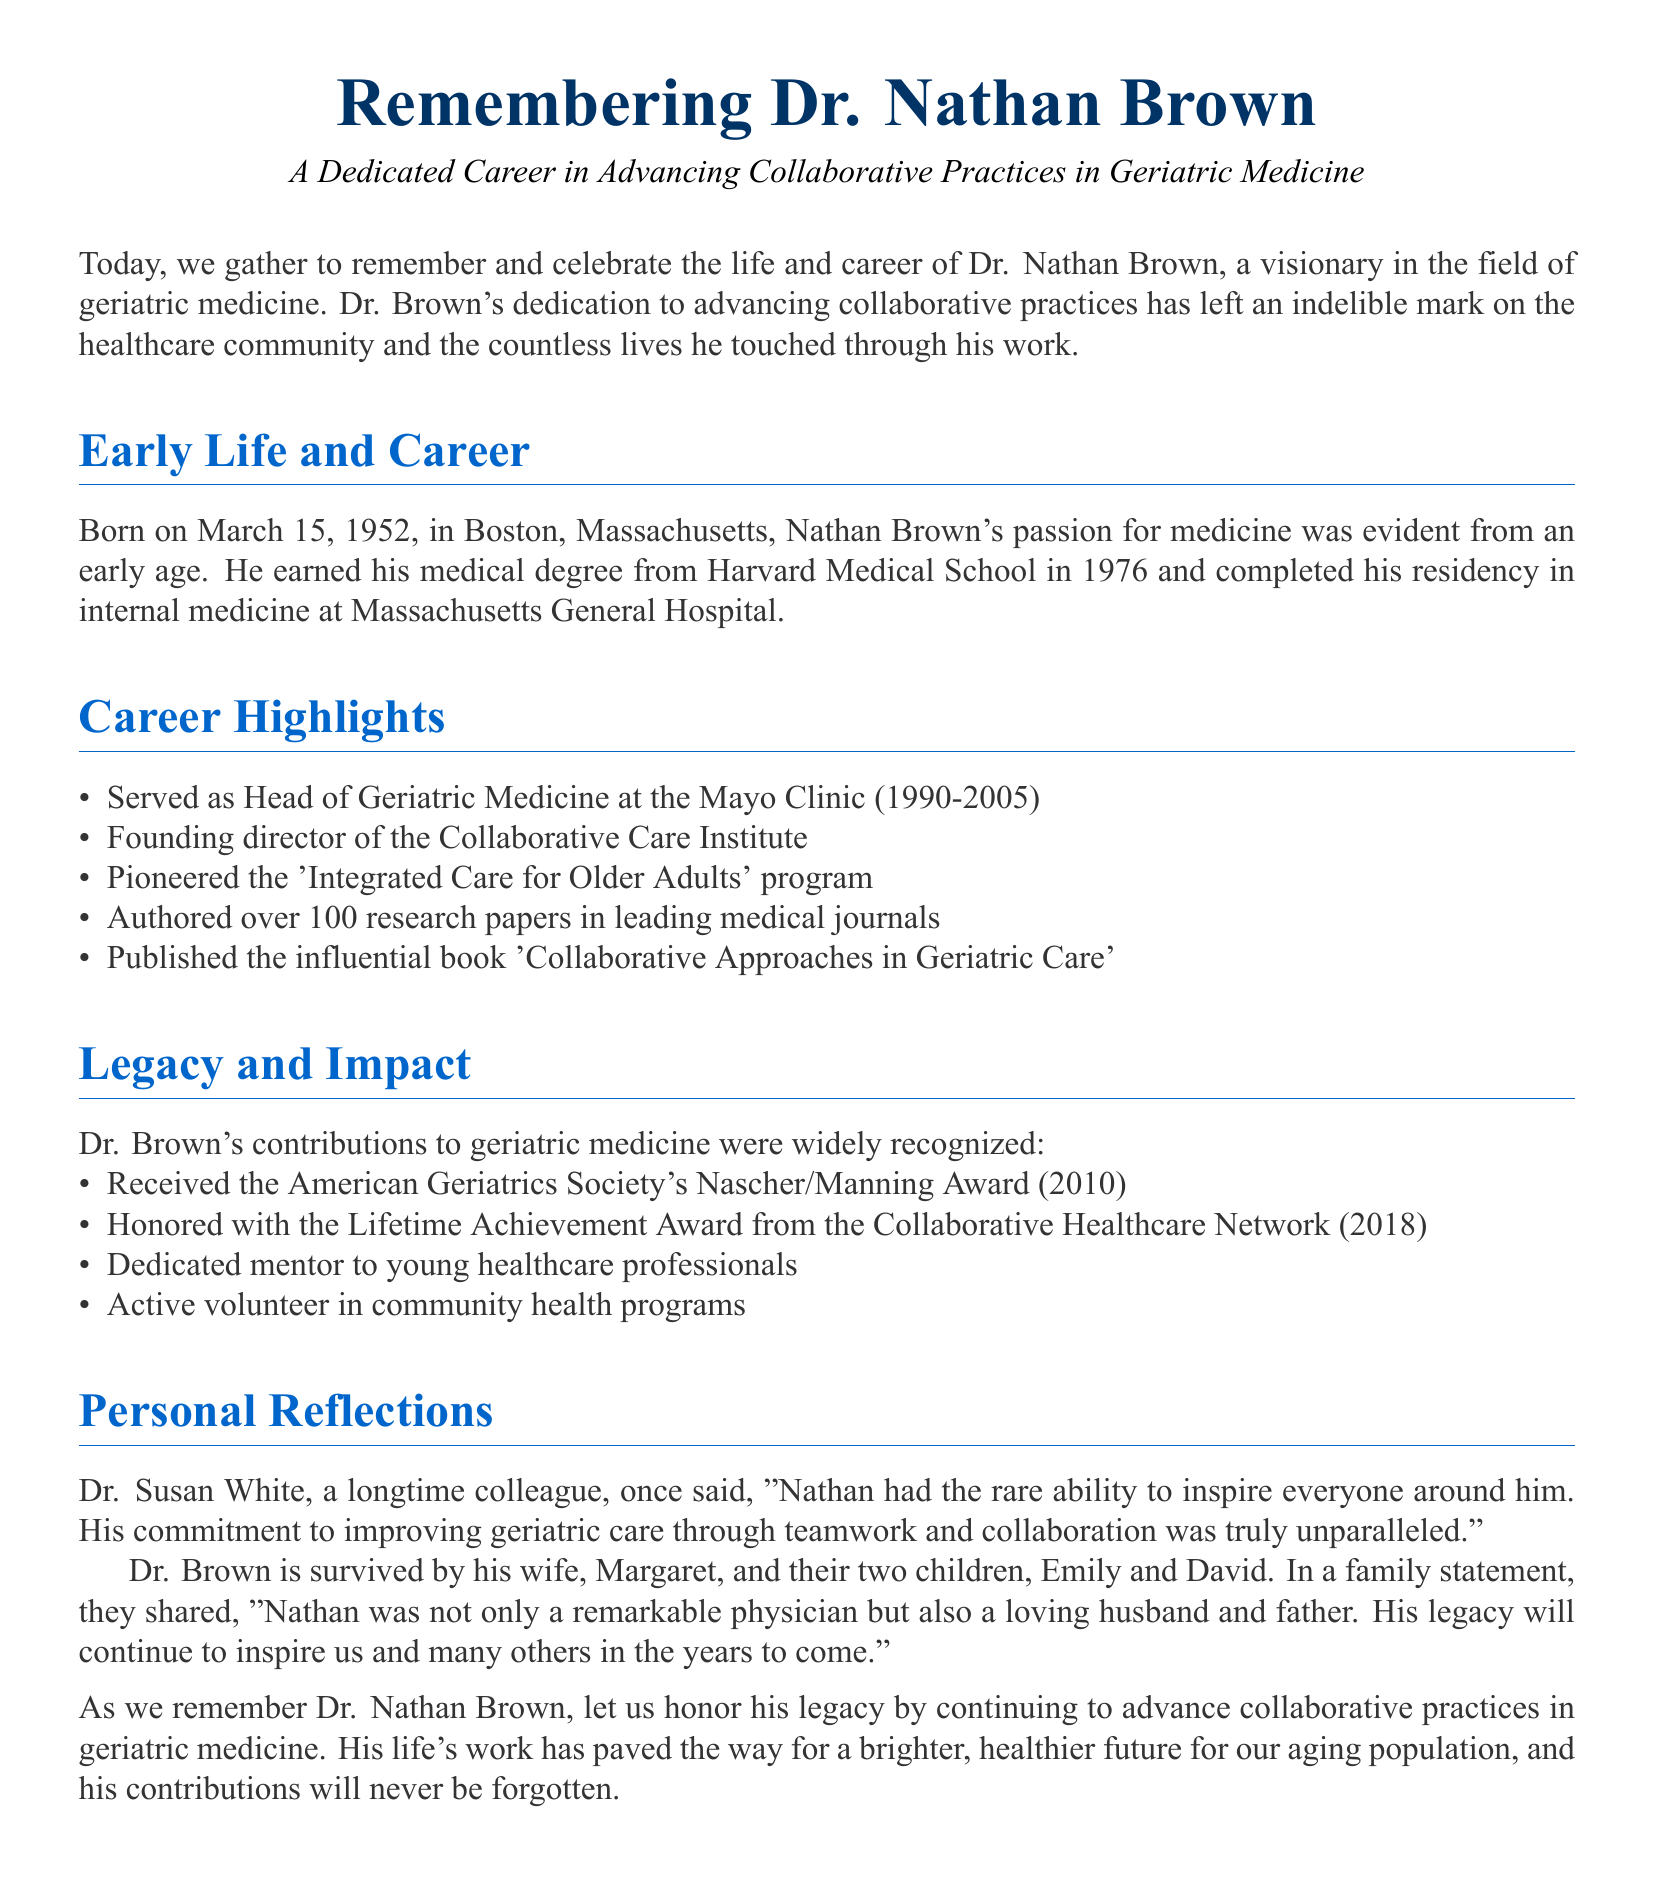What date was Dr. Nathan Brown born? The document states that Dr. Nathan Brown was born on March 15, 1952.
Answer: March 15, 1952 What award did Dr. Brown receive in 2010? The document mentions that he received the American Geriatrics Society's Nascher/Manning Award in 2010.
Answer: Nascher/Manning Award What was the title of Dr. Brown's influential book? The document specifies that he published the book titled 'Collaborative Approaches in Geriatric Care'.
Answer: Collaborative Approaches in Geriatric Care How many research papers did Dr. Brown author? According to the document, Dr. Brown authored over 100 research papers in leading medical journals.
Answer: Over 100 Who is Dr. Brown survived by? The document states that Dr. Brown is survived by his wife, Margaret, and their two children, Emily and David.
Answer: Margaret, Emily, and David What role did Dr. Brown serve at the Mayo Clinic? The document expresses that he served as Head of Geriatric Medicine at the Mayo Clinic from 1990 to 2005.
Answer: Head of Geriatric Medicine What program did Dr. Brown pioneer? The document indicates that he pioneered the 'Integrated Care for Older Adults' program.
Answer: Integrated Care for Older Adults Who described Dr. Brown's inspiring ability? The document cites Dr. Susan White as a colleague who described Dr. Brown's inspiring ability.
Answer: Dr. Susan White What did the family statement emphasize about Dr. Brown? The family statement emphasized that Nathan was a remarkable physician and a loving husband and father.
Answer: Remarkable physician and loving husband and father 